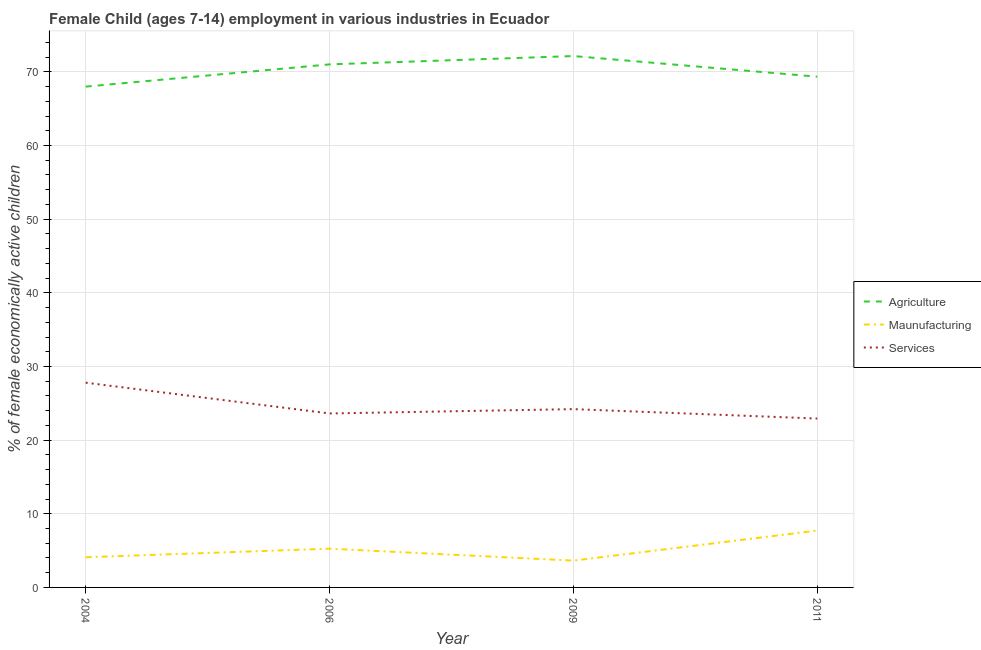Does the line corresponding to percentage of economically active children in manufacturing intersect with the line corresponding to percentage of economically active children in agriculture?
Offer a terse response. No. What is the percentage of economically active children in services in 2006?
Your answer should be compact. 23.62. Across all years, what is the maximum percentage of economically active children in agriculture?
Ensure brevity in your answer.  72.15. Across all years, what is the minimum percentage of economically active children in agriculture?
Offer a very short reply. 68. In which year was the percentage of economically active children in manufacturing maximum?
Offer a terse response. 2011. What is the total percentage of economically active children in manufacturing in the graph?
Make the answer very short. 20.72. What is the difference between the percentage of economically active children in manufacturing in 2006 and that in 2011?
Your answer should be compact. -2.46. What is the difference between the percentage of economically active children in manufacturing in 2006 and the percentage of economically active children in agriculture in 2009?
Provide a short and direct response. -66.89. What is the average percentage of economically active children in services per year?
Your answer should be very brief. 24.64. In the year 2011, what is the difference between the percentage of economically active children in manufacturing and percentage of economically active children in services?
Ensure brevity in your answer.  -15.21. In how many years, is the percentage of economically active children in services greater than 68 %?
Offer a terse response. 0. What is the ratio of the percentage of economically active children in agriculture in 2006 to that in 2011?
Your answer should be very brief. 1.02. What is the difference between the highest and the second highest percentage of economically active children in manufacturing?
Offer a very short reply. 2.46. What is the difference between the highest and the lowest percentage of economically active children in manufacturing?
Your response must be concise. 4.08. In how many years, is the percentage of economically active children in agriculture greater than the average percentage of economically active children in agriculture taken over all years?
Provide a succinct answer. 2. Is the sum of the percentage of economically active children in services in 2004 and 2009 greater than the maximum percentage of economically active children in manufacturing across all years?
Your answer should be compact. Yes. Is it the case that in every year, the sum of the percentage of economically active children in agriculture and percentage of economically active children in manufacturing is greater than the percentage of economically active children in services?
Offer a terse response. Yes. Is the percentage of economically active children in manufacturing strictly less than the percentage of economically active children in agriculture over the years?
Make the answer very short. Yes. What is the difference between two consecutive major ticks on the Y-axis?
Give a very brief answer. 10. Are the values on the major ticks of Y-axis written in scientific E-notation?
Provide a succinct answer. No. Does the graph contain any zero values?
Your answer should be very brief. No. How are the legend labels stacked?
Make the answer very short. Vertical. What is the title of the graph?
Your answer should be compact. Female Child (ages 7-14) employment in various industries in Ecuador. What is the label or title of the Y-axis?
Offer a very short reply. % of female economically active children. What is the % of female economically active children in Maunufacturing in 2004?
Provide a succinct answer. 4.1. What is the % of female economically active children in Services in 2004?
Offer a terse response. 27.8. What is the % of female economically active children of Agriculture in 2006?
Provide a short and direct response. 71.02. What is the % of female economically active children in Maunufacturing in 2006?
Your answer should be compact. 5.26. What is the % of female economically active children of Services in 2006?
Your response must be concise. 23.62. What is the % of female economically active children of Agriculture in 2009?
Your response must be concise. 72.15. What is the % of female economically active children of Maunufacturing in 2009?
Provide a succinct answer. 3.64. What is the % of female economically active children in Services in 2009?
Ensure brevity in your answer.  24.21. What is the % of female economically active children in Agriculture in 2011?
Your answer should be very brief. 69.35. What is the % of female economically active children of Maunufacturing in 2011?
Keep it short and to the point. 7.72. What is the % of female economically active children of Services in 2011?
Your answer should be very brief. 22.93. Across all years, what is the maximum % of female economically active children in Agriculture?
Provide a succinct answer. 72.15. Across all years, what is the maximum % of female economically active children in Maunufacturing?
Keep it short and to the point. 7.72. Across all years, what is the maximum % of female economically active children of Services?
Ensure brevity in your answer.  27.8. Across all years, what is the minimum % of female economically active children of Maunufacturing?
Your response must be concise. 3.64. Across all years, what is the minimum % of female economically active children in Services?
Give a very brief answer. 22.93. What is the total % of female economically active children in Agriculture in the graph?
Give a very brief answer. 280.52. What is the total % of female economically active children in Maunufacturing in the graph?
Provide a succinct answer. 20.72. What is the total % of female economically active children in Services in the graph?
Offer a terse response. 98.56. What is the difference between the % of female economically active children in Agriculture in 2004 and that in 2006?
Your answer should be compact. -3.02. What is the difference between the % of female economically active children in Maunufacturing in 2004 and that in 2006?
Give a very brief answer. -1.16. What is the difference between the % of female economically active children of Services in 2004 and that in 2006?
Your response must be concise. 4.18. What is the difference between the % of female economically active children in Agriculture in 2004 and that in 2009?
Give a very brief answer. -4.15. What is the difference between the % of female economically active children of Maunufacturing in 2004 and that in 2009?
Provide a short and direct response. 0.46. What is the difference between the % of female economically active children of Services in 2004 and that in 2009?
Your answer should be compact. 3.59. What is the difference between the % of female economically active children in Agriculture in 2004 and that in 2011?
Keep it short and to the point. -1.35. What is the difference between the % of female economically active children in Maunufacturing in 2004 and that in 2011?
Your response must be concise. -3.62. What is the difference between the % of female economically active children in Services in 2004 and that in 2011?
Keep it short and to the point. 4.87. What is the difference between the % of female economically active children of Agriculture in 2006 and that in 2009?
Give a very brief answer. -1.13. What is the difference between the % of female economically active children of Maunufacturing in 2006 and that in 2009?
Give a very brief answer. 1.62. What is the difference between the % of female economically active children in Services in 2006 and that in 2009?
Offer a terse response. -0.59. What is the difference between the % of female economically active children in Agriculture in 2006 and that in 2011?
Your answer should be very brief. 1.67. What is the difference between the % of female economically active children of Maunufacturing in 2006 and that in 2011?
Give a very brief answer. -2.46. What is the difference between the % of female economically active children of Services in 2006 and that in 2011?
Provide a succinct answer. 0.69. What is the difference between the % of female economically active children in Maunufacturing in 2009 and that in 2011?
Your answer should be compact. -4.08. What is the difference between the % of female economically active children in Services in 2009 and that in 2011?
Ensure brevity in your answer.  1.28. What is the difference between the % of female economically active children in Agriculture in 2004 and the % of female economically active children in Maunufacturing in 2006?
Your answer should be very brief. 62.74. What is the difference between the % of female economically active children in Agriculture in 2004 and the % of female economically active children in Services in 2006?
Make the answer very short. 44.38. What is the difference between the % of female economically active children in Maunufacturing in 2004 and the % of female economically active children in Services in 2006?
Ensure brevity in your answer.  -19.52. What is the difference between the % of female economically active children in Agriculture in 2004 and the % of female economically active children in Maunufacturing in 2009?
Give a very brief answer. 64.36. What is the difference between the % of female economically active children of Agriculture in 2004 and the % of female economically active children of Services in 2009?
Your answer should be very brief. 43.79. What is the difference between the % of female economically active children in Maunufacturing in 2004 and the % of female economically active children in Services in 2009?
Provide a succinct answer. -20.11. What is the difference between the % of female economically active children in Agriculture in 2004 and the % of female economically active children in Maunufacturing in 2011?
Your answer should be very brief. 60.28. What is the difference between the % of female economically active children of Agriculture in 2004 and the % of female economically active children of Services in 2011?
Your answer should be very brief. 45.07. What is the difference between the % of female economically active children in Maunufacturing in 2004 and the % of female economically active children in Services in 2011?
Your answer should be compact. -18.83. What is the difference between the % of female economically active children in Agriculture in 2006 and the % of female economically active children in Maunufacturing in 2009?
Provide a succinct answer. 67.38. What is the difference between the % of female economically active children in Agriculture in 2006 and the % of female economically active children in Services in 2009?
Provide a short and direct response. 46.81. What is the difference between the % of female economically active children in Maunufacturing in 2006 and the % of female economically active children in Services in 2009?
Make the answer very short. -18.95. What is the difference between the % of female economically active children in Agriculture in 2006 and the % of female economically active children in Maunufacturing in 2011?
Offer a terse response. 63.3. What is the difference between the % of female economically active children of Agriculture in 2006 and the % of female economically active children of Services in 2011?
Your response must be concise. 48.09. What is the difference between the % of female economically active children in Maunufacturing in 2006 and the % of female economically active children in Services in 2011?
Keep it short and to the point. -17.67. What is the difference between the % of female economically active children of Agriculture in 2009 and the % of female economically active children of Maunufacturing in 2011?
Provide a succinct answer. 64.43. What is the difference between the % of female economically active children in Agriculture in 2009 and the % of female economically active children in Services in 2011?
Your response must be concise. 49.22. What is the difference between the % of female economically active children of Maunufacturing in 2009 and the % of female economically active children of Services in 2011?
Provide a short and direct response. -19.29. What is the average % of female economically active children of Agriculture per year?
Your response must be concise. 70.13. What is the average % of female economically active children in Maunufacturing per year?
Ensure brevity in your answer.  5.18. What is the average % of female economically active children of Services per year?
Your answer should be compact. 24.64. In the year 2004, what is the difference between the % of female economically active children in Agriculture and % of female economically active children in Maunufacturing?
Your response must be concise. 63.9. In the year 2004, what is the difference between the % of female economically active children in Agriculture and % of female economically active children in Services?
Your answer should be very brief. 40.2. In the year 2004, what is the difference between the % of female economically active children of Maunufacturing and % of female economically active children of Services?
Your answer should be very brief. -23.7. In the year 2006, what is the difference between the % of female economically active children in Agriculture and % of female economically active children in Maunufacturing?
Make the answer very short. 65.76. In the year 2006, what is the difference between the % of female economically active children of Agriculture and % of female economically active children of Services?
Your answer should be compact. 47.4. In the year 2006, what is the difference between the % of female economically active children of Maunufacturing and % of female economically active children of Services?
Provide a succinct answer. -18.36. In the year 2009, what is the difference between the % of female economically active children of Agriculture and % of female economically active children of Maunufacturing?
Your response must be concise. 68.51. In the year 2009, what is the difference between the % of female economically active children in Agriculture and % of female economically active children in Services?
Ensure brevity in your answer.  47.94. In the year 2009, what is the difference between the % of female economically active children of Maunufacturing and % of female economically active children of Services?
Provide a succinct answer. -20.57. In the year 2011, what is the difference between the % of female economically active children in Agriculture and % of female economically active children in Maunufacturing?
Keep it short and to the point. 61.63. In the year 2011, what is the difference between the % of female economically active children in Agriculture and % of female economically active children in Services?
Provide a succinct answer. 46.42. In the year 2011, what is the difference between the % of female economically active children of Maunufacturing and % of female economically active children of Services?
Your response must be concise. -15.21. What is the ratio of the % of female economically active children of Agriculture in 2004 to that in 2006?
Your answer should be compact. 0.96. What is the ratio of the % of female economically active children in Maunufacturing in 2004 to that in 2006?
Make the answer very short. 0.78. What is the ratio of the % of female economically active children of Services in 2004 to that in 2006?
Ensure brevity in your answer.  1.18. What is the ratio of the % of female economically active children in Agriculture in 2004 to that in 2009?
Make the answer very short. 0.94. What is the ratio of the % of female economically active children in Maunufacturing in 2004 to that in 2009?
Keep it short and to the point. 1.13. What is the ratio of the % of female economically active children in Services in 2004 to that in 2009?
Your answer should be very brief. 1.15. What is the ratio of the % of female economically active children in Agriculture in 2004 to that in 2011?
Offer a very short reply. 0.98. What is the ratio of the % of female economically active children of Maunufacturing in 2004 to that in 2011?
Provide a short and direct response. 0.53. What is the ratio of the % of female economically active children in Services in 2004 to that in 2011?
Provide a succinct answer. 1.21. What is the ratio of the % of female economically active children in Agriculture in 2006 to that in 2009?
Offer a terse response. 0.98. What is the ratio of the % of female economically active children of Maunufacturing in 2006 to that in 2009?
Provide a short and direct response. 1.45. What is the ratio of the % of female economically active children in Services in 2006 to that in 2009?
Offer a terse response. 0.98. What is the ratio of the % of female economically active children of Agriculture in 2006 to that in 2011?
Make the answer very short. 1.02. What is the ratio of the % of female economically active children in Maunufacturing in 2006 to that in 2011?
Ensure brevity in your answer.  0.68. What is the ratio of the % of female economically active children in Services in 2006 to that in 2011?
Make the answer very short. 1.03. What is the ratio of the % of female economically active children in Agriculture in 2009 to that in 2011?
Your answer should be very brief. 1.04. What is the ratio of the % of female economically active children in Maunufacturing in 2009 to that in 2011?
Your response must be concise. 0.47. What is the ratio of the % of female economically active children in Services in 2009 to that in 2011?
Ensure brevity in your answer.  1.06. What is the difference between the highest and the second highest % of female economically active children of Agriculture?
Your answer should be very brief. 1.13. What is the difference between the highest and the second highest % of female economically active children in Maunufacturing?
Provide a succinct answer. 2.46. What is the difference between the highest and the second highest % of female economically active children of Services?
Ensure brevity in your answer.  3.59. What is the difference between the highest and the lowest % of female economically active children in Agriculture?
Ensure brevity in your answer.  4.15. What is the difference between the highest and the lowest % of female economically active children in Maunufacturing?
Your answer should be compact. 4.08. What is the difference between the highest and the lowest % of female economically active children in Services?
Provide a succinct answer. 4.87. 